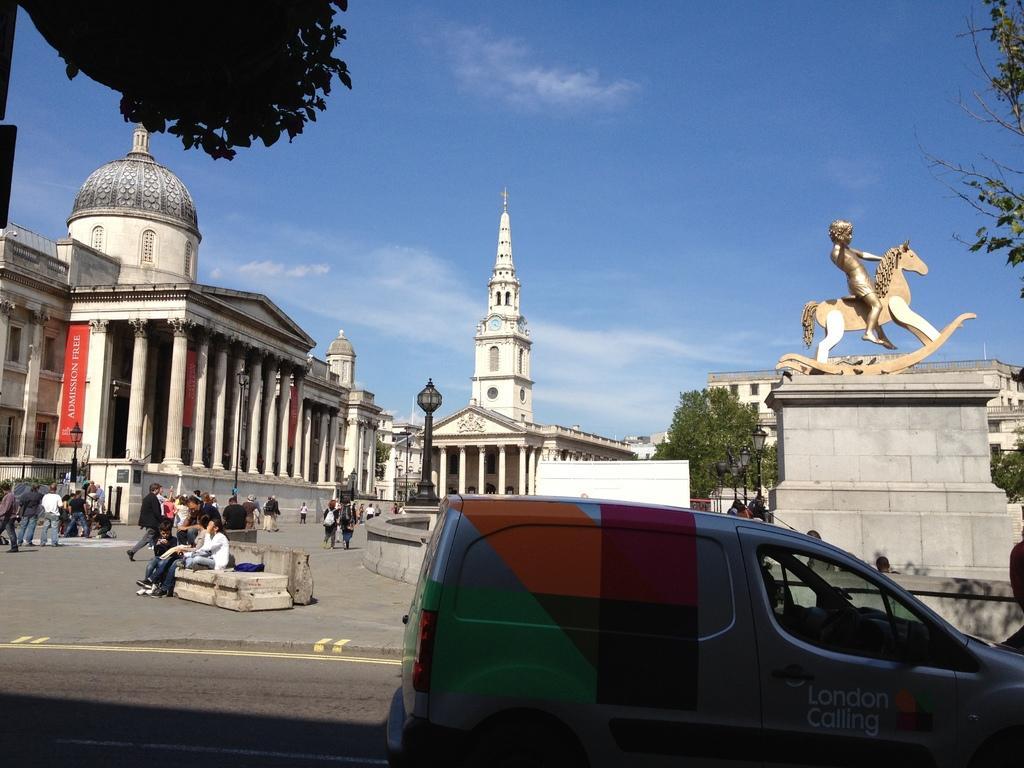Describe this image in one or two sentences. In this image, we can see a vehicle, people, buildings, trees, poles, towers, statue. 